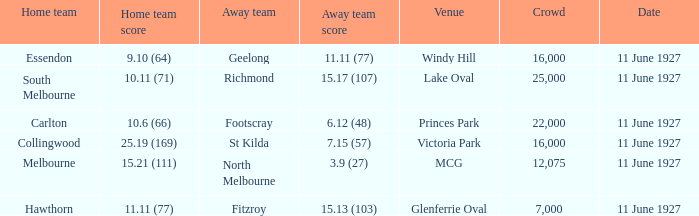What is the sum of all crowds present at the Glenferrie Oval venue? 7000.0. 